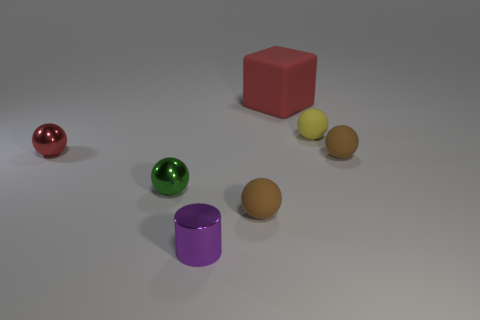What material is the yellow ball that is the same size as the purple cylinder?
Provide a succinct answer. Rubber. There is a shiny ball in front of the red metal thing that is in front of the tiny yellow sphere; is there a big red object that is to the left of it?
Give a very brief answer. No. Is there anything else that has the same shape as the tiny green thing?
Provide a succinct answer. Yes. There is a metallic object behind the small green metal object; is it the same color as the small sphere that is to the right of the small yellow matte object?
Your answer should be compact. No. Is there a red sphere?
Your response must be concise. Yes. What size is the red object that is right of the small metal object in front of the brown sphere on the left side of the large object?
Give a very brief answer. Large. There is a tiny yellow rubber thing; is its shape the same as the brown rubber object on the left side of the rubber block?
Keep it short and to the point. Yes. Is there another matte block of the same color as the block?
Your answer should be compact. No. How many cubes are tiny brown rubber objects or rubber objects?
Ensure brevity in your answer.  1. Are there any tiny brown rubber things of the same shape as the yellow thing?
Your response must be concise. Yes. 